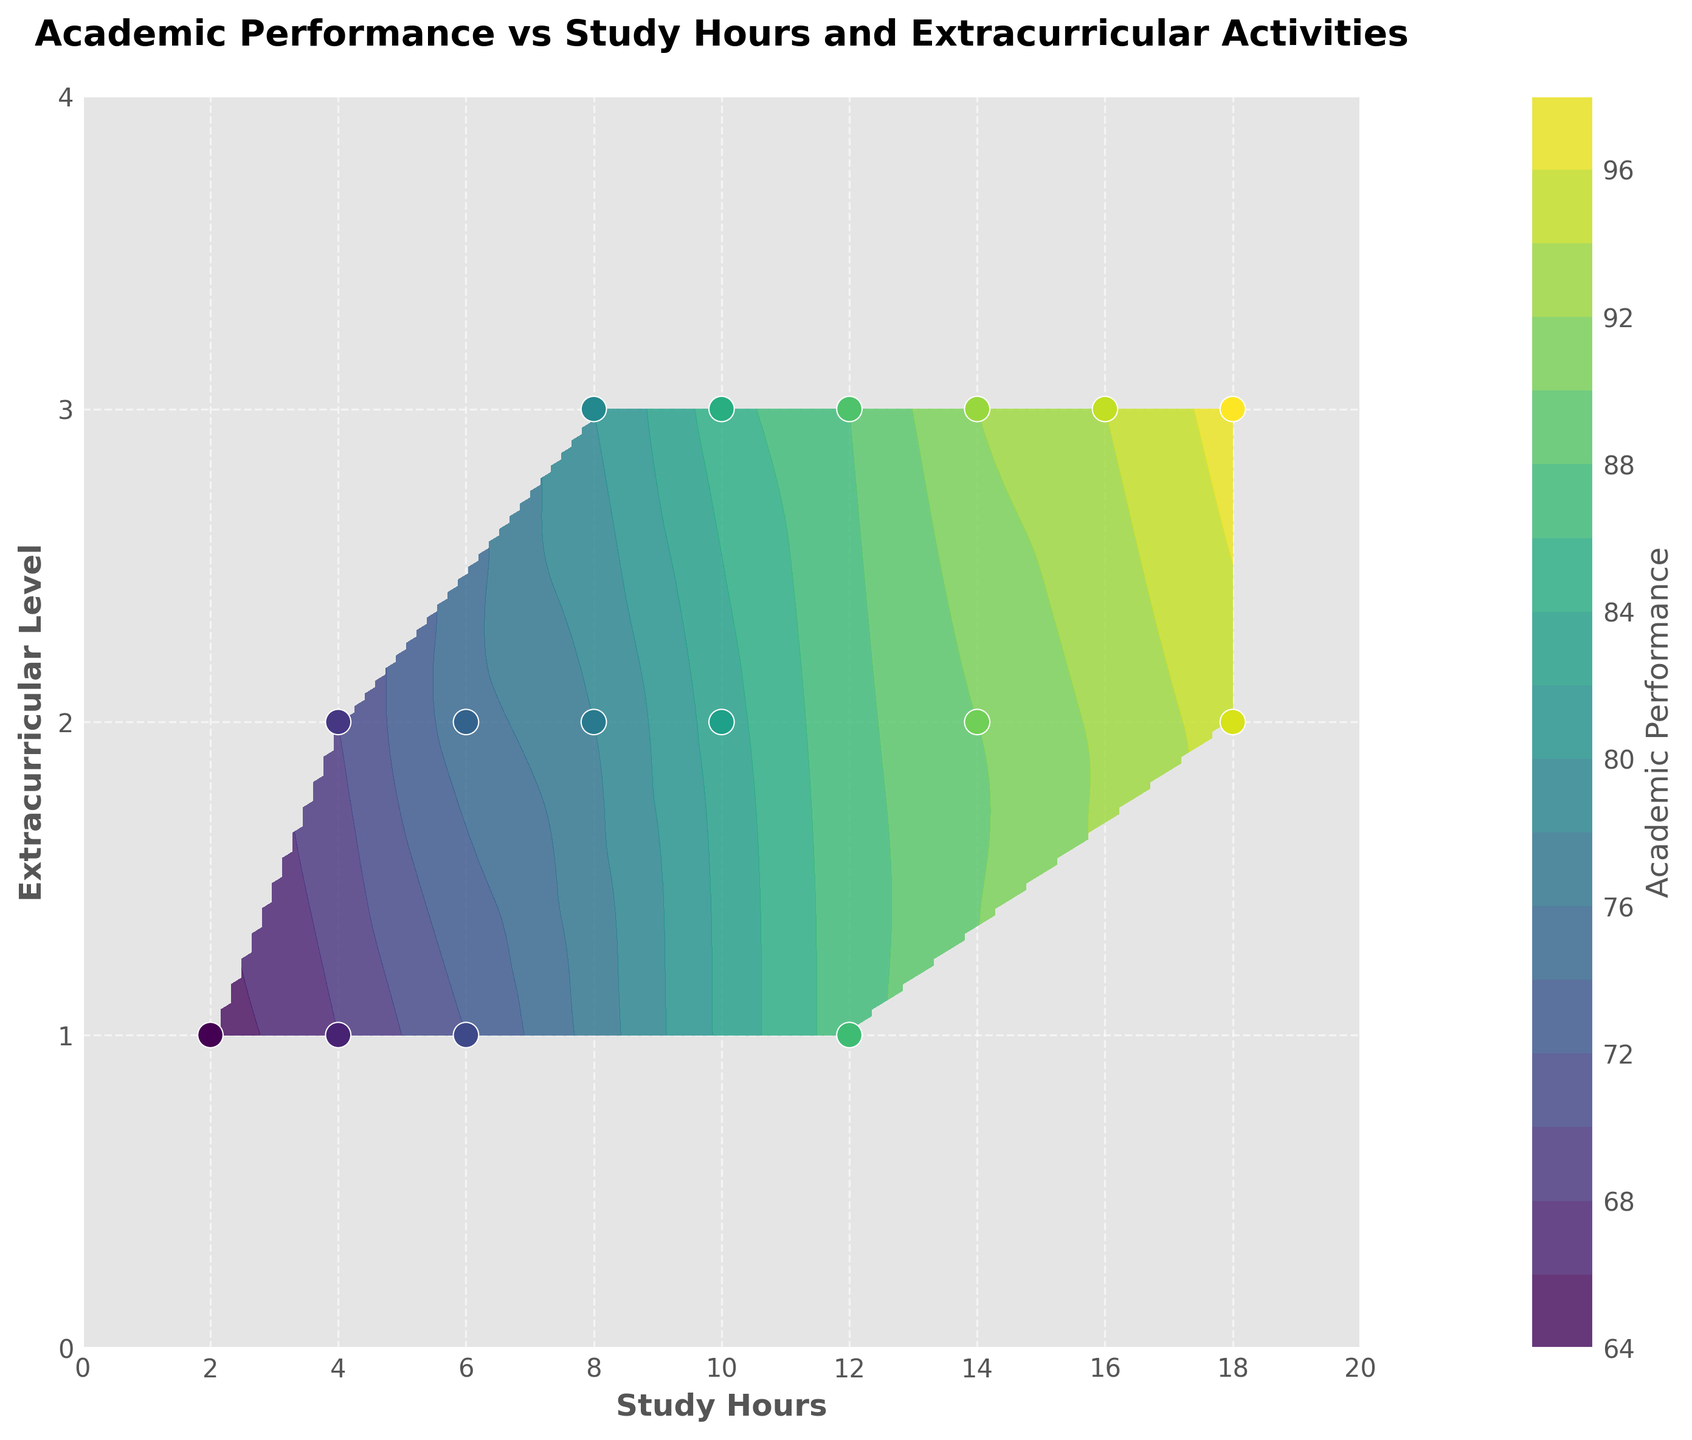What's the title of the figure? The title of the figure is found at the top and summarizes what the graph represents.
Answer: Academic Performance vs Study Hours and Extracurricular Activities What is the range of study hours represented on the x-axis? The x-axis represents the number of study hours, and the ticks go from 0 to 20 hours. The range is from 0 to 20 hours.
Answer: 0 to 20 How many data points are shown in the figure? By counting the number of scatter points overlaid on the contour plot, we can determine the number of data points.
Answer: 16 What's the highest academic performance as shown in the plot? Look at the color bar on the right to find the color representing the highest value, and then locate the corresponding data point on the plot.
Answer: 97 What study hours correspond to the highest academic performance? Find the data point representing the highest academic performance and locate its position on the x-axis, which shows the study hours.
Answer: 18 How does academic performance change as study hours increase for the same extracurricular level? Observe a constant extracurricular level (e.g., 2) and see how the academic performance (color intensity) varies with increasing study hours.
Answer: Increases Which combination of study hours and extracurricular level appears most frequently in the high-performance range (around 90 and above)? High-performance range can be derived from color intensity in the contour plot, around 90 and above. Identify the regions where this occurs frequently.
Answer: 14-18 study hours and level 2-3 extracurricular How does academic performance at 8 study hours and extracurricular level 2 compare to 12 study hours and extracurricular level 1? Locate the two points on the plot and compare their color intensity or precise numerical academic performance values annotated at those points.
Answer: 78 vs 87 Is there a visible peak in academic performance on the contour plot? If so, where? Identifying the highest concentration of the lightest color (representing higher values) in the contour plot to determine the peak's location.
Answer: Yes, at 18 study hours and extracurricular level 3 At a consistent extracurricular level, does doubling the study hours generally result in a higher academic performance? Compare the academic performance values when study hours are doubled at the same extracurricular level. Use the contour plot's gradient as a reference.
Answer: Generally, yes 